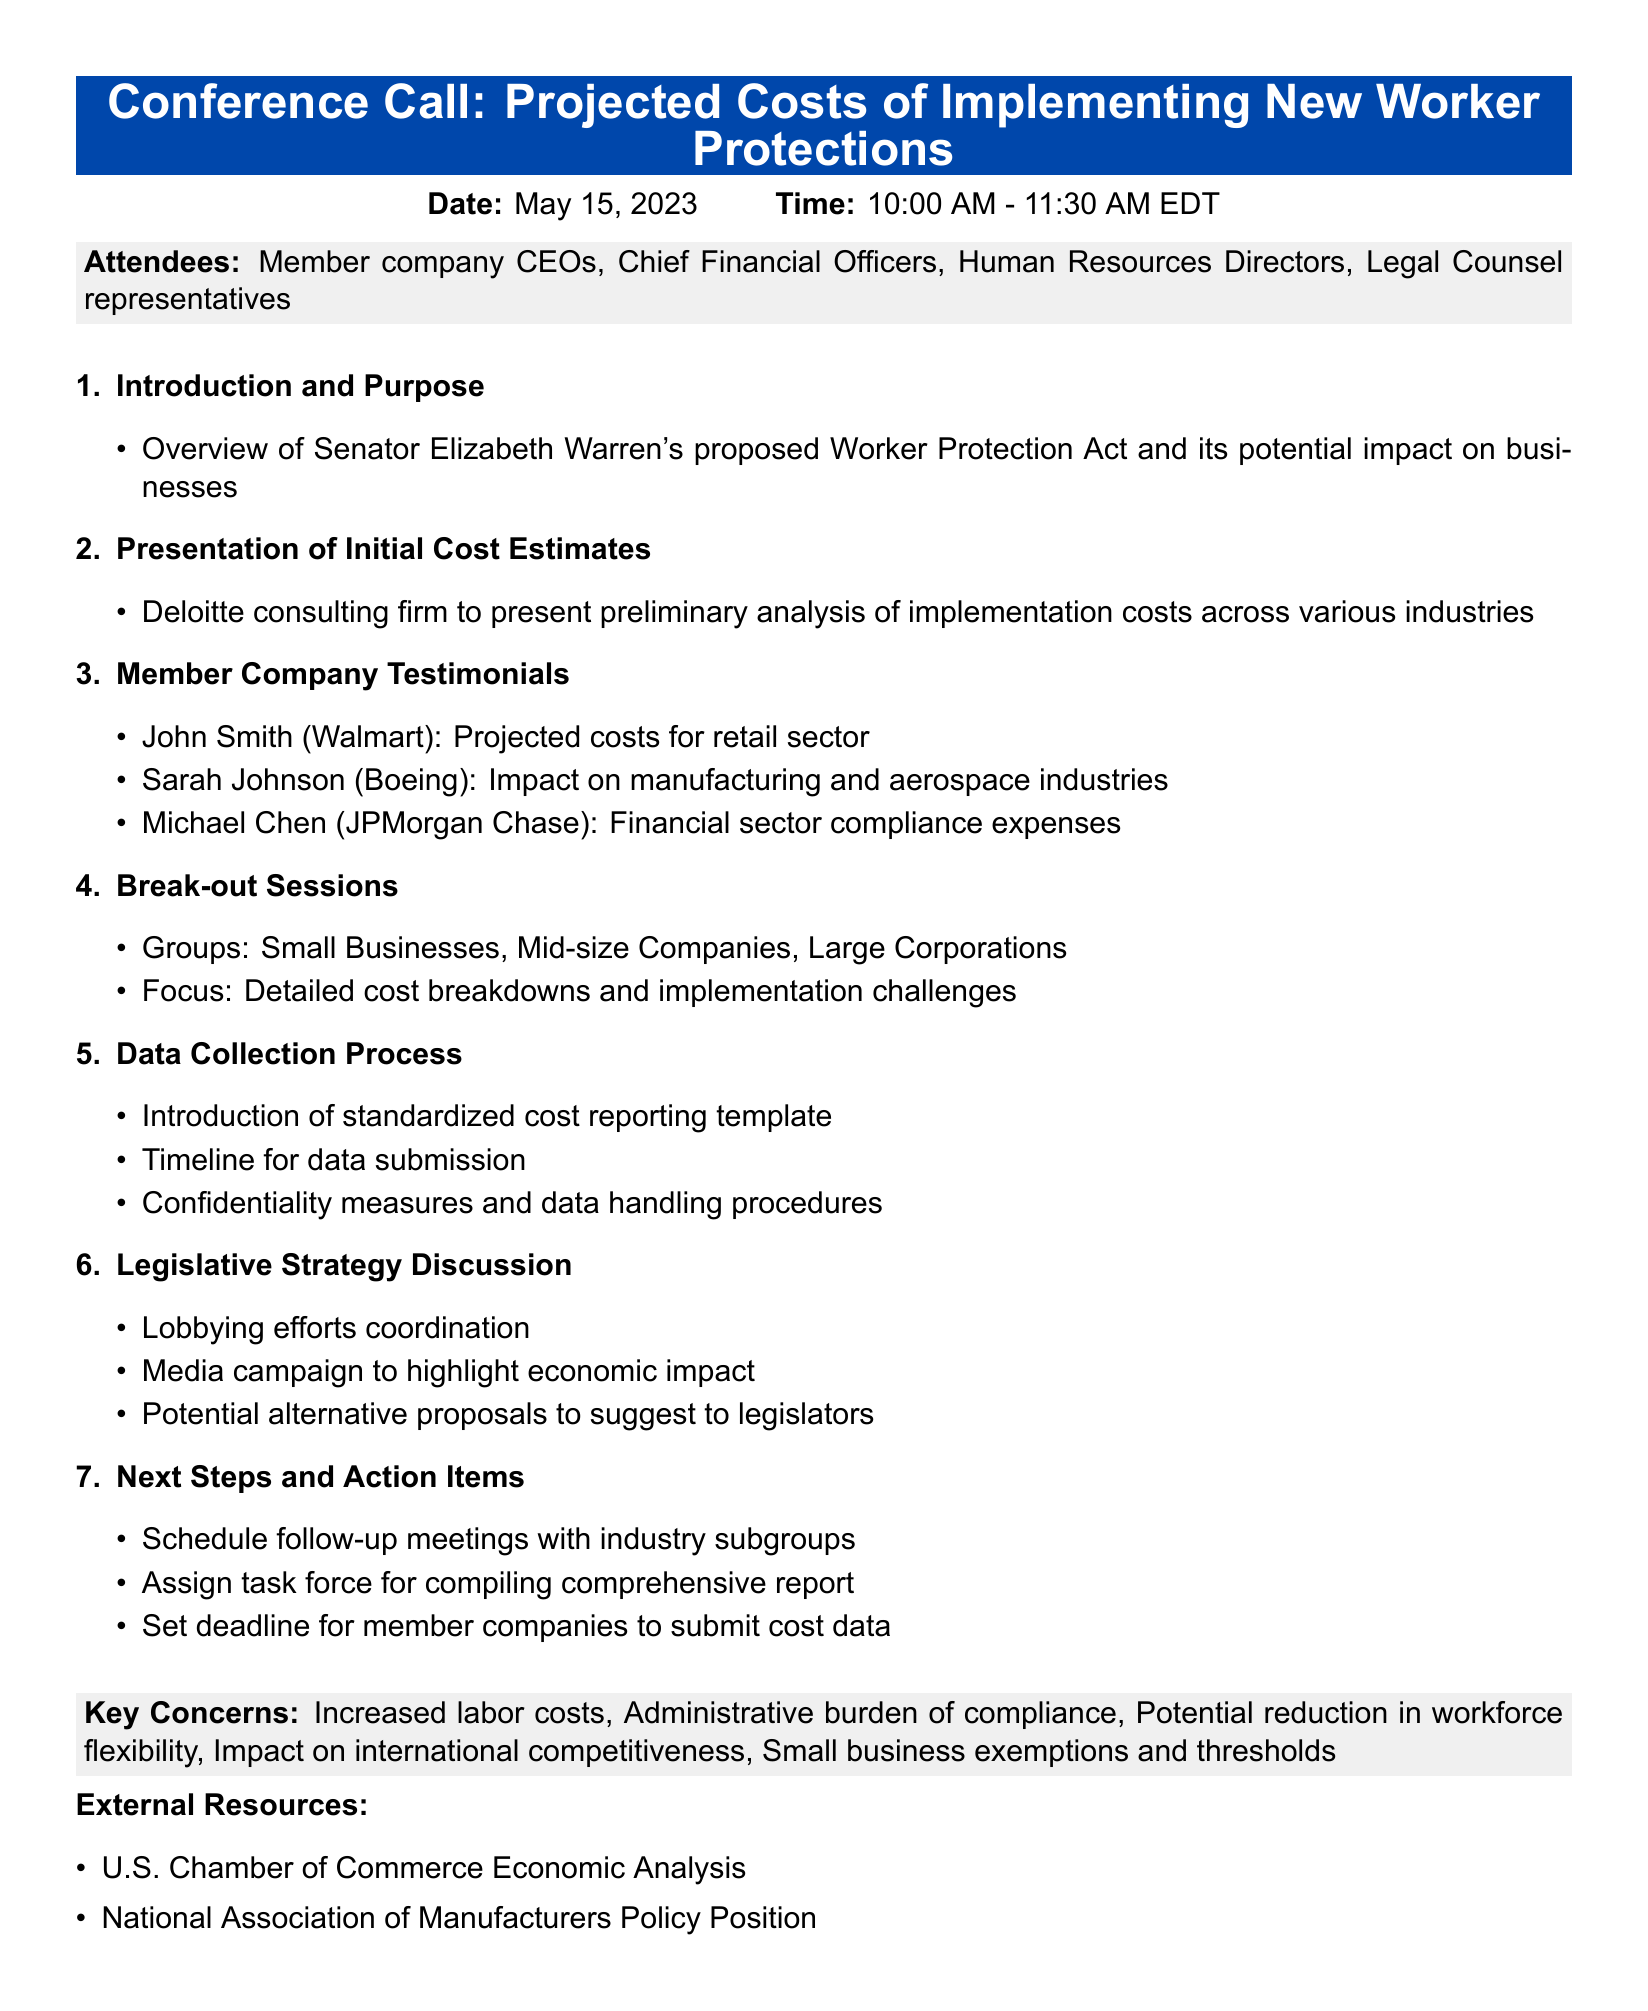What is the title of the meeting? The title is provided at the top of the document.
Answer: Conference Call: Projected Costs of Implementing New Worker Protections What is the date of the meeting? The date is specified in the meeting details section.
Answer: May 15, 2023 Who is presenting the initial cost estimates? The document mentions the presenting firm in the agenda item.
Answer: Deloitte consulting firm What are the three focus group types in the break-out sessions? The document lists groups specified under break-out sessions.
Answer: Small Businesses, Mid-size Companies, Large Corporations What is one of the key concerns raised about the legislation? The key concerns were listed in a specific section of the document.
Answer: Increased labor costs What is the main purpose of the conference call? The purpose is outlined in the introduction section.
Answer: Overview of Senator Elizabeth Warren's proposed Worker Protection Act and its potential impact on businesses What kind of template will be introduced for data collection? The document specifies the type of reporting tool mentioned in the agenda.
Answer: Standardized cost reporting template What is one action item related to next steps? The next steps include specific actions detailed in the agenda.
Answer: Schedule follow-up meetings with industry subgroups What impact does the legislation have on international competitiveness? This concern is highlighted as part of the key issues associated with the proposed act.
Answer: Impact on international competitiveness 